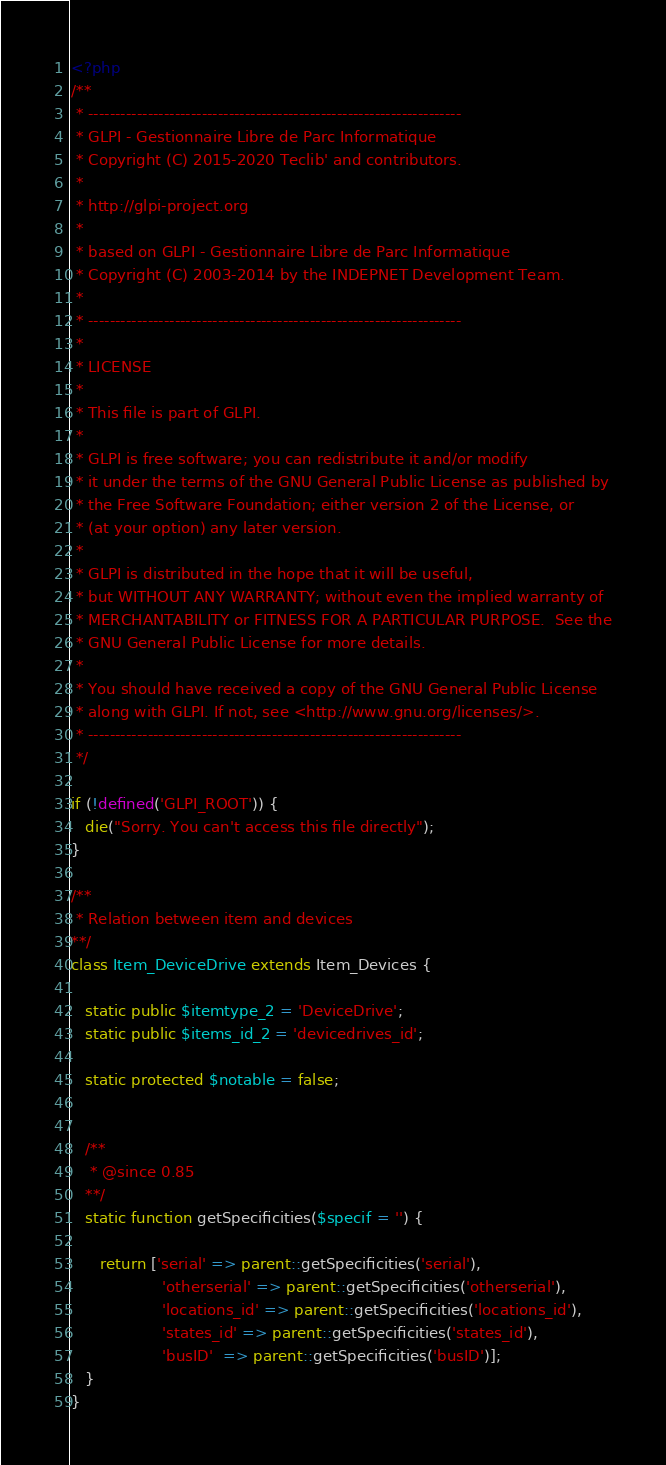Convert code to text. <code><loc_0><loc_0><loc_500><loc_500><_PHP_><?php
/**
 * ---------------------------------------------------------------------
 * GLPI - Gestionnaire Libre de Parc Informatique
 * Copyright (C) 2015-2020 Teclib' and contributors.
 *
 * http://glpi-project.org
 *
 * based on GLPI - Gestionnaire Libre de Parc Informatique
 * Copyright (C) 2003-2014 by the INDEPNET Development Team.
 *
 * ---------------------------------------------------------------------
 *
 * LICENSE
 *
 * This file is part of GLPI.
 *
 * GLPI is free software; you can redistribute it and/or modify
 * it under the terms of the GNU General Public License as published by
 * the Free Software Foundation; either version 2 of the License, or
 * (at your option) any later version.
 *
 * GLPI is distributed in the hope that it will be useful,
 * but WITHOUT ANY WARRANTY; without even the implied warranty of
 * MERCHANTABILITY or FITNESS FOR A PARTICULAR PURPOSE.  See the
 * GNU General Public License for more details.
 *
 * You should have received a copy of the GNU General Public License
 * along with GLPI. If not, see <http://www.gnu.org/licenses/>.
 * ---------------------------------------------------------------------
 */

if (!defined('GLPI_ROOT')) {
   die("Sorry. You can't access this file directly");
}

/**
 * Relation between item and devices
**/
class Item_DeviceDrive extends Item_Devices {

   static public $itemtype_2 = 'DeviceDrive';
   static public $items_id_2 = 'devicedrives_id';

   static protected $notable = false;


   /**
    * @since 0.85
   **/
   static function getSpecificities($specif = '') {

      return ['serial' => parent::getSpecificities('serial'),
                   'otherserial' => parent::getSpecificities('otherserial'),
                   'locations_id' => parent::getSpecificities('locations_id'),
                   'states_id' => parent::getSpecificities('states_id'),
                   'busID'  => parent::getSpecificities('busID')];
   }
}
</code> 